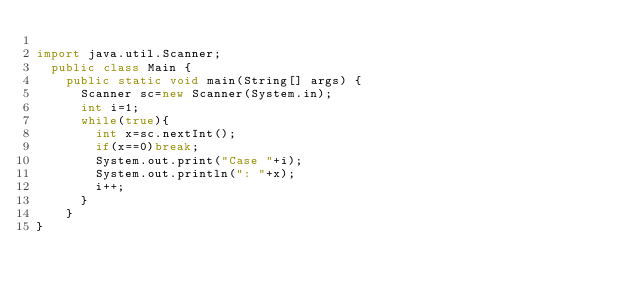Convert code to text. <code><loc_0><loc_0><loc_500><loc_500><_Java_>
import java.util.Scanner;
	public class Main {
		public static void main(String[] args) {
			Scanner sc=new Scanner(System.in);
			int i=1;
			while(true){
				int x=sc.nextInt();
				if(x==0)break;
				System.out.print("Case "+i);
				System.out.println(": "+x);
				i++;
			}
		}
}</code> 